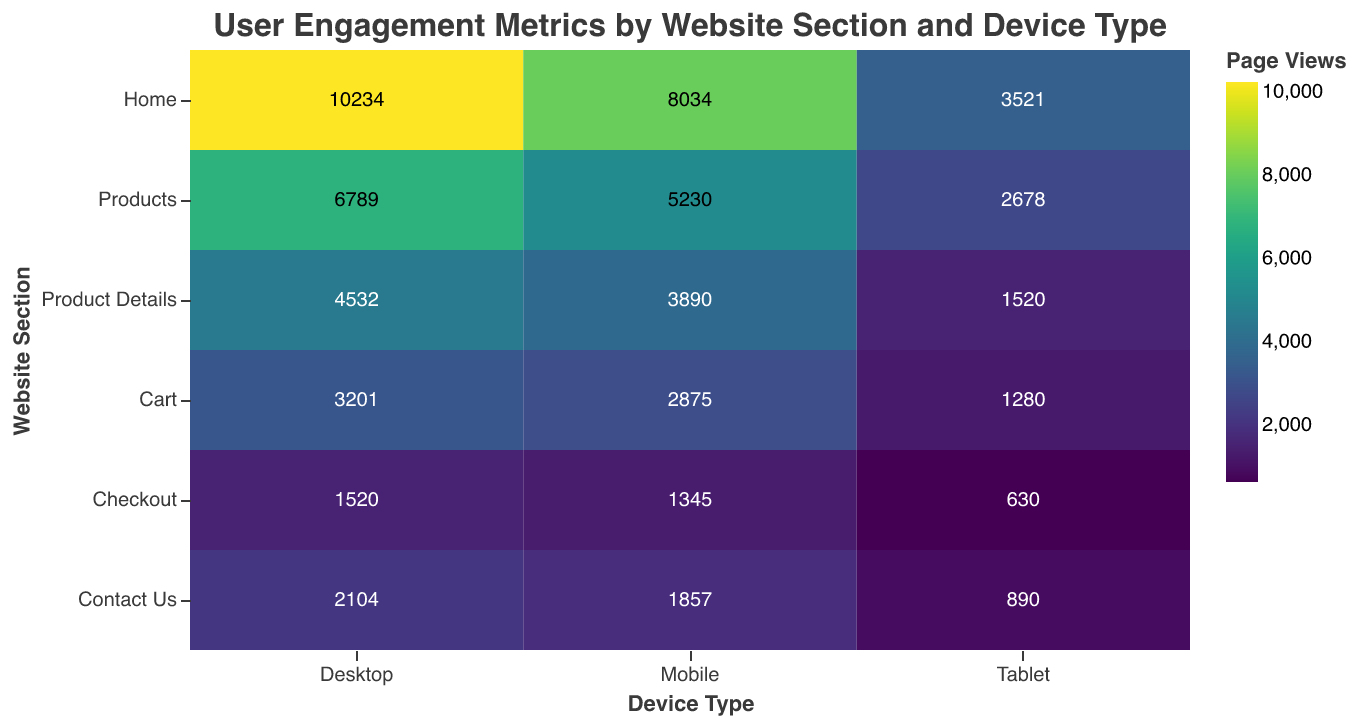What is the title of the heatmap? The title is visually presented at the top of the heatmap, clearly stating the purpose of the heatmap.
Answer: User Engagement Metrics by Website Section and Device Type Which device type has the highest number of page views for the "Home" section? By looking at the "Home" section row and comparing the page view values for each device type, the highest number is found under "Desktop".
Answer: Desktop What is the average bounce rate for the "Checkout" section across all device types? Adding the bounce rates for "Desktop" (18%), "Mobile" (30%), and "Tablet" (28%) gives 76%. Dividing by 3 gives an average of 25.33%.
Answer: 25.33% Which website section has the highest average time on page for mobile devices? By comparing the average time on page for mobile devices across all sections, the "Checkout" section has the highest value of 165 seconds.
Answer: Checkout How does the conversion rate for mobile devices compare between the "Cart" and "Products" sections? The conversion rate for mobile devices is 8.9% in the "Cart" section and 4.2% in the "Products" section. 8.9% is greater than 4.2%.
Answer: Mobile conversion rate is higher in "Cart" Find the section with the highest conversion rate across all device types. By identifying the maximum conversion rates in each section across all device types, "Checkout" section has the highest conversion rate with 25% for Desktop.
Answer: Checkout Which device type has the lowest page views for the "Product Details" section? Comparing the page views for each device type in the "Product Details" section, the lowest page views are under "Tablet" with 1520.
Answer: Tablet What is the difference in average time on page between "Home" and "Product Details" sections for desktop devices? The average time on page for "Home" is 85s and for "Product Details" is 120s. The difference is 120 - 85 = 35s.
Answer: 35 seconds Compare the bounce rate of the "Contact Us" section for Tablet and Mobile devices. The bounce rate for "Contact Us" on Tablet devices is 58% and on Mobile devices is 65%. Thus, Mobile has a higher bounce rate.
Answer: Mobile has a higher bounce rate Which section has the lowest conversion rate overall, and what is this value? By comparing the conversion rates across all sections, "Contact Us" section has the lowest conversion rate with 0.9% on Mobile devices.
Answer: Contact Us, 0.9% 